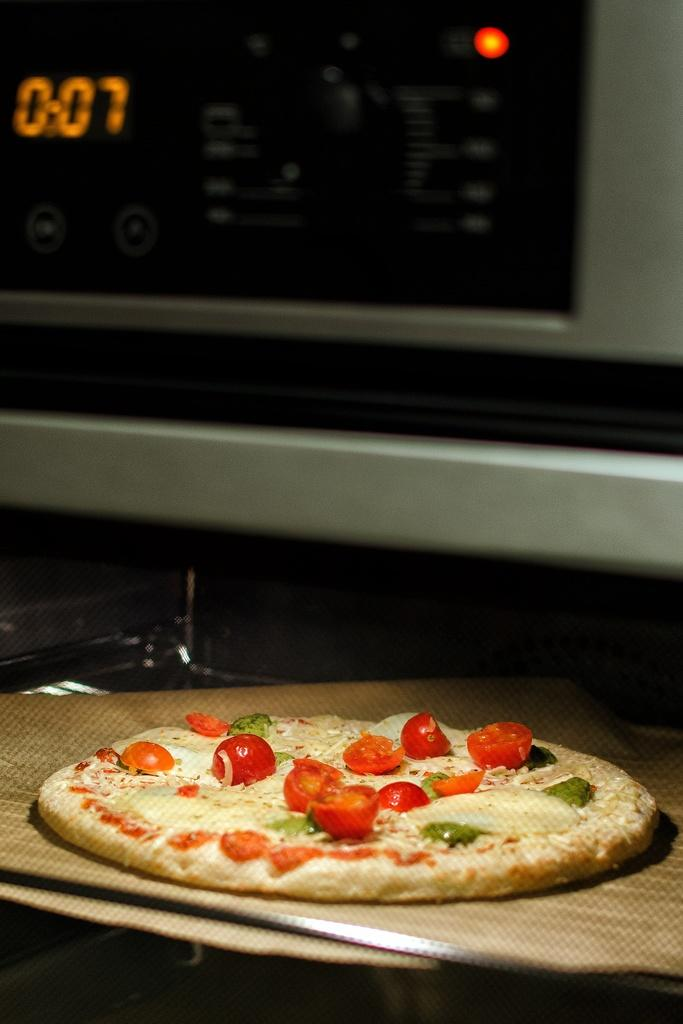<image>
Summarize the visual content of the image. a pizza sitting on a counter in front of a clock reading 0:07 